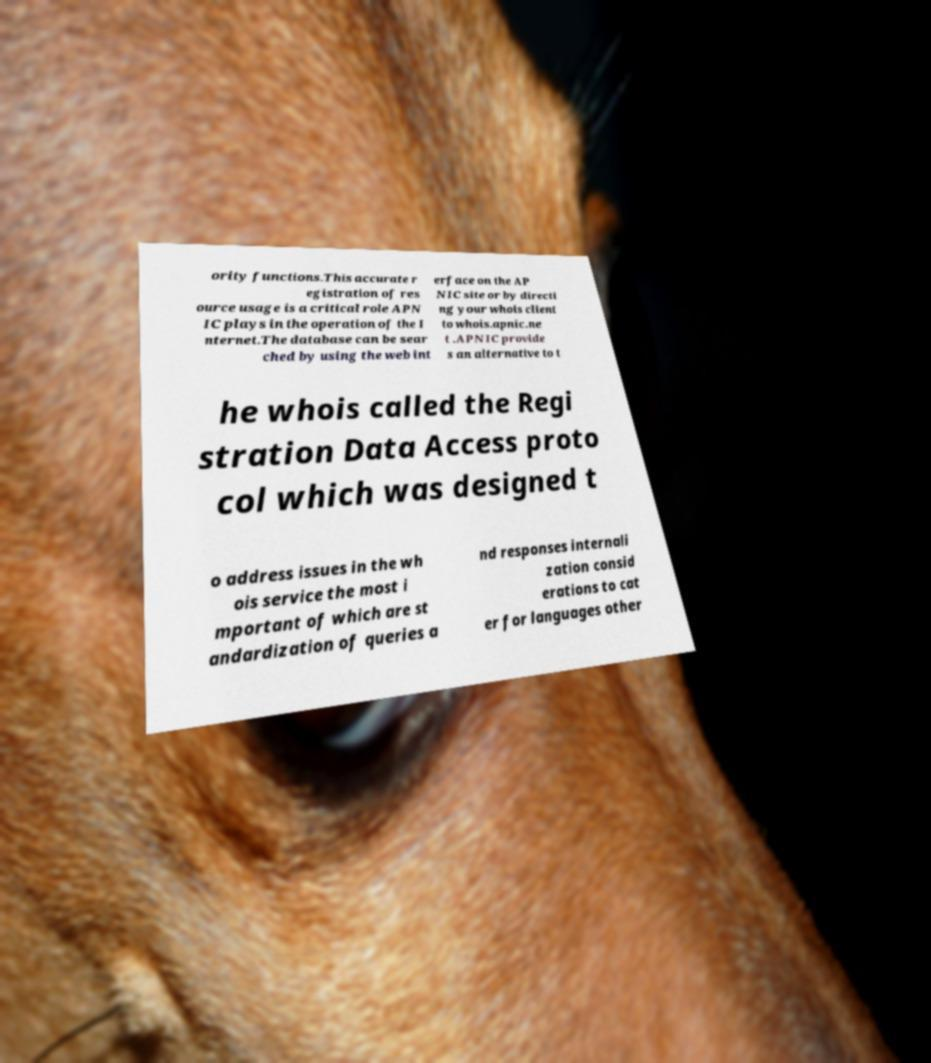There's text embedded in this image that I need extracted. Can you transcribe it verbatim? ority functions.This accurate r egistration of res ource usage is a critical role APN IC plays in the operation of the I nternet.The database can be sear ched by using the web int erface on the AP NIC site or by directi ng your whois client to whois.apnic.ne t .APNIC provide s an alternative to t he whois called the Regi stration Data Access proto col which was designed t o address issues in the wh ois service the most i mportant of which are st andardization of queries a nd responses internali zation consid erations to cat er for languages other 